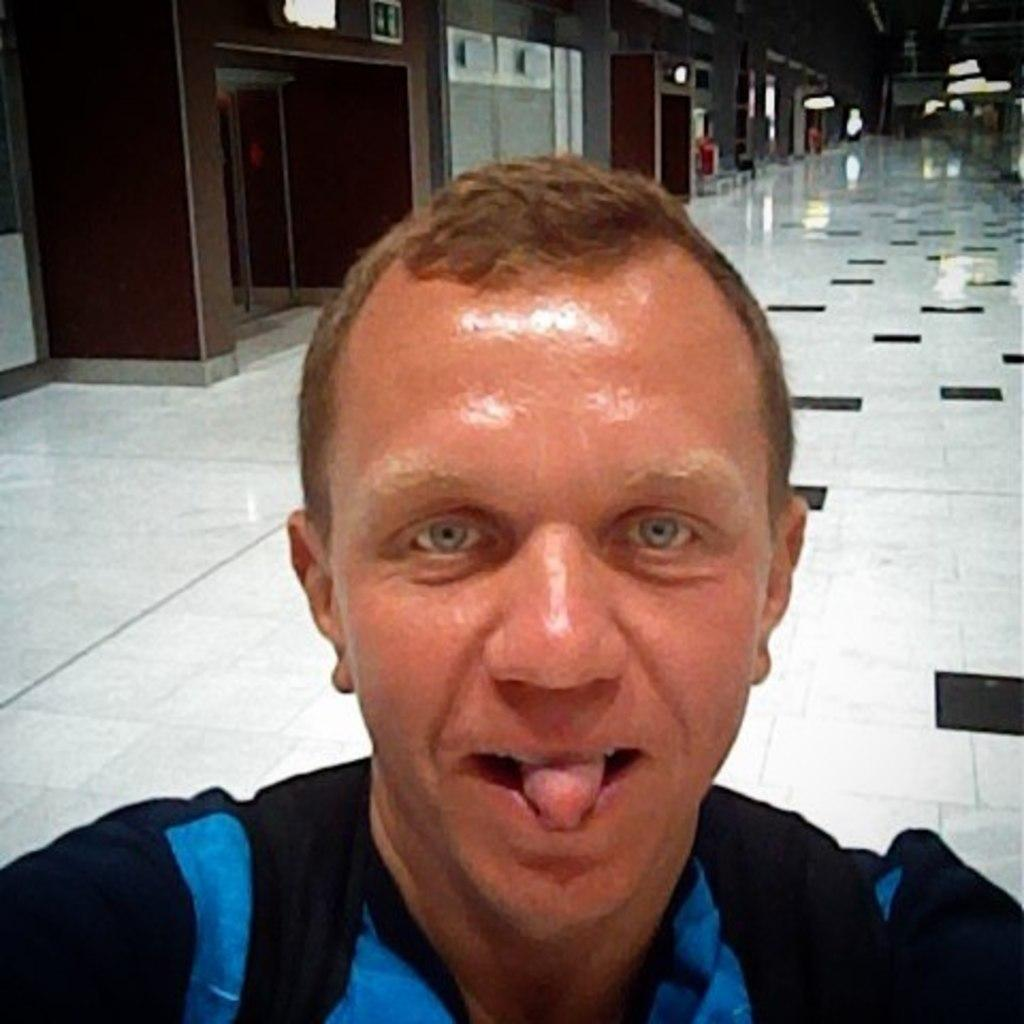What is present in the image? There is a man in the image. What can be seen in the background of the image? There are doors, walls, and lights in the background of the image. Is there a maid in the image? There is no mention of a maid in the image or the provided facts. What is the value of the man in the image? The value of the man cannot be determined from the image or the provided facts. 